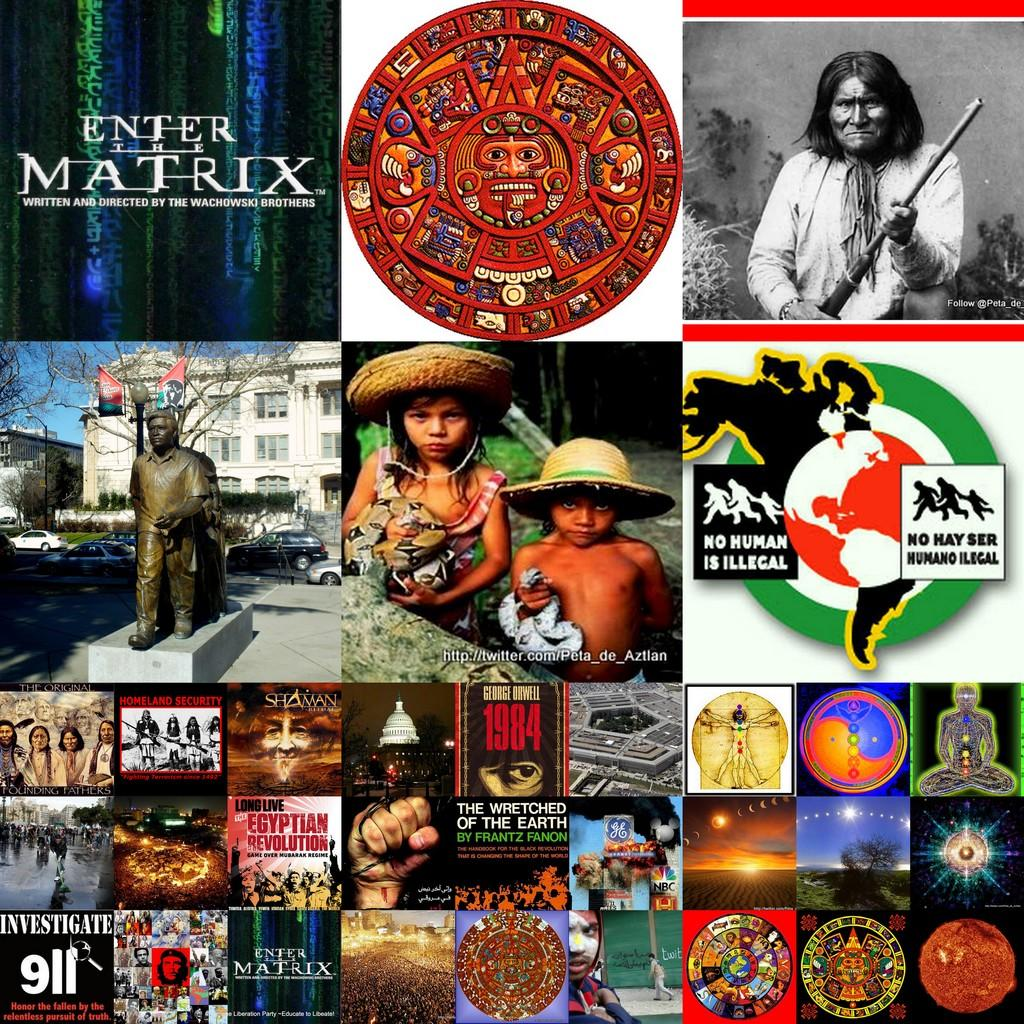What is featured on the poster in the image? There is a poster in the image, and it has logos and text on it. Who or what can be seen in the image besides the poster? There are people, buildings, trees, vehicles, and a walkway in the image. What type of plantation can be seen in the image? There is no plantation present in the image. What argument is being made in the image? The image does not depict an argument or any form of debate. 